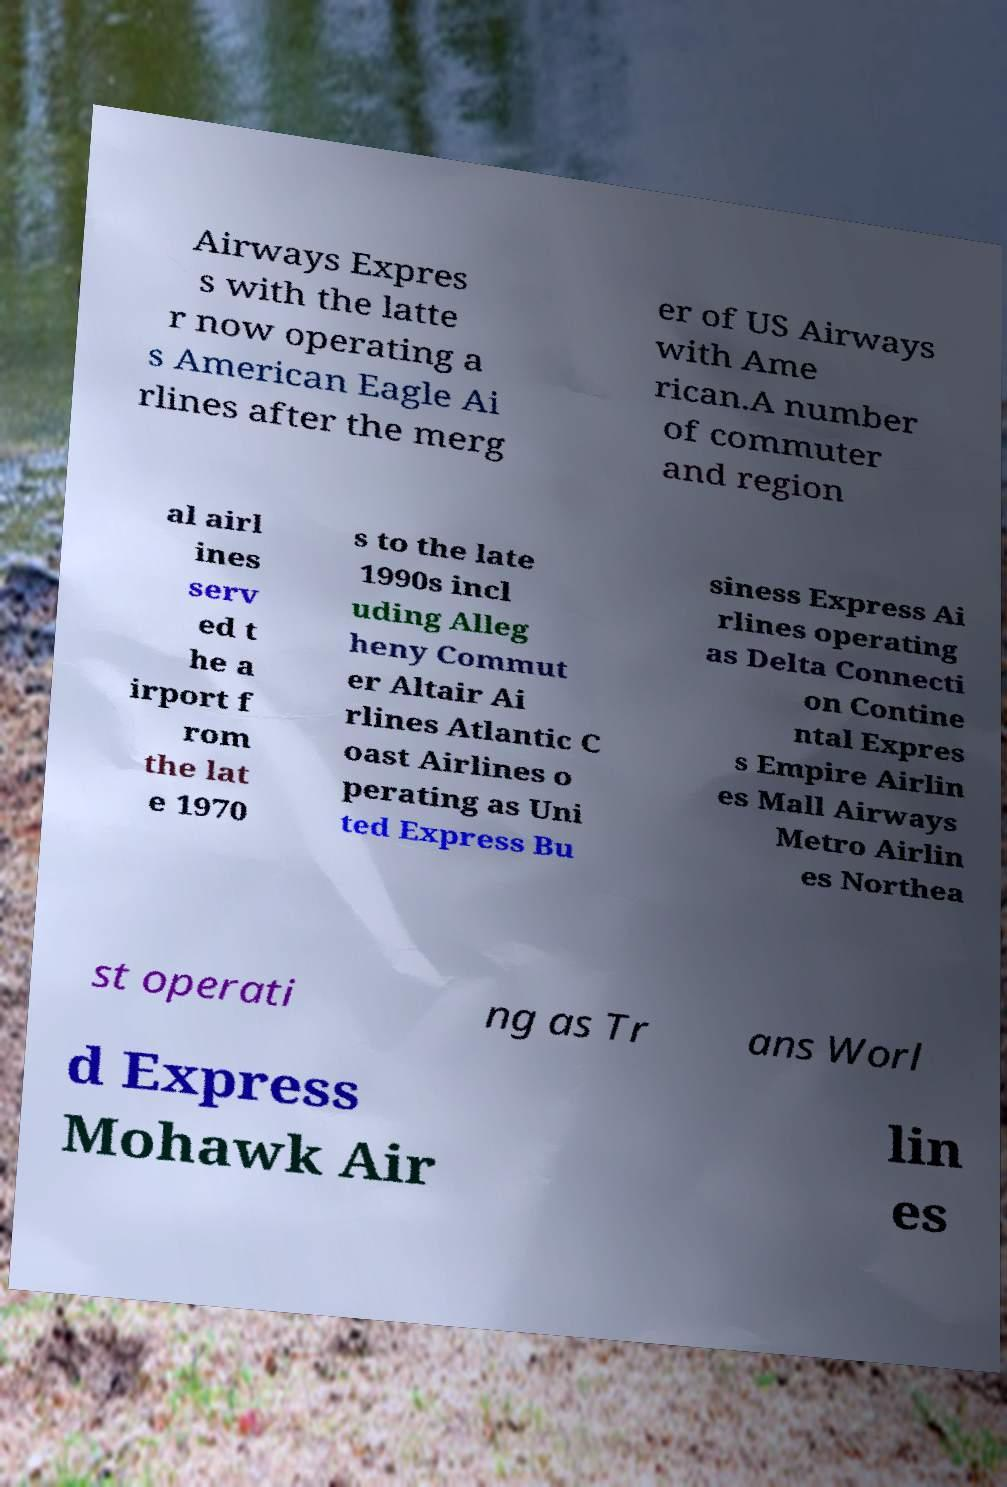Could you extract and type out the text from this image? Airways Expres s with the latte r now operating a s American Eagle Ai rlines after the merg er of US Airways with Ame rican.A number of commuter and region al airl ines serv ed t he a irport f rom the lat e 1970 s to the late 1990s incl uding Alleg heny Commut er Altair Ai rlines Atlantic C oast Airlines o perating as Uni ted Express Bu siness Express Ai rlines operating as Delta Connecti on Contine ntal Expres s Empire Airlin es Mall Airways Metro Airlin es Northea st operati ng as Tr ans Worl d Express Mohawk Air lin es 